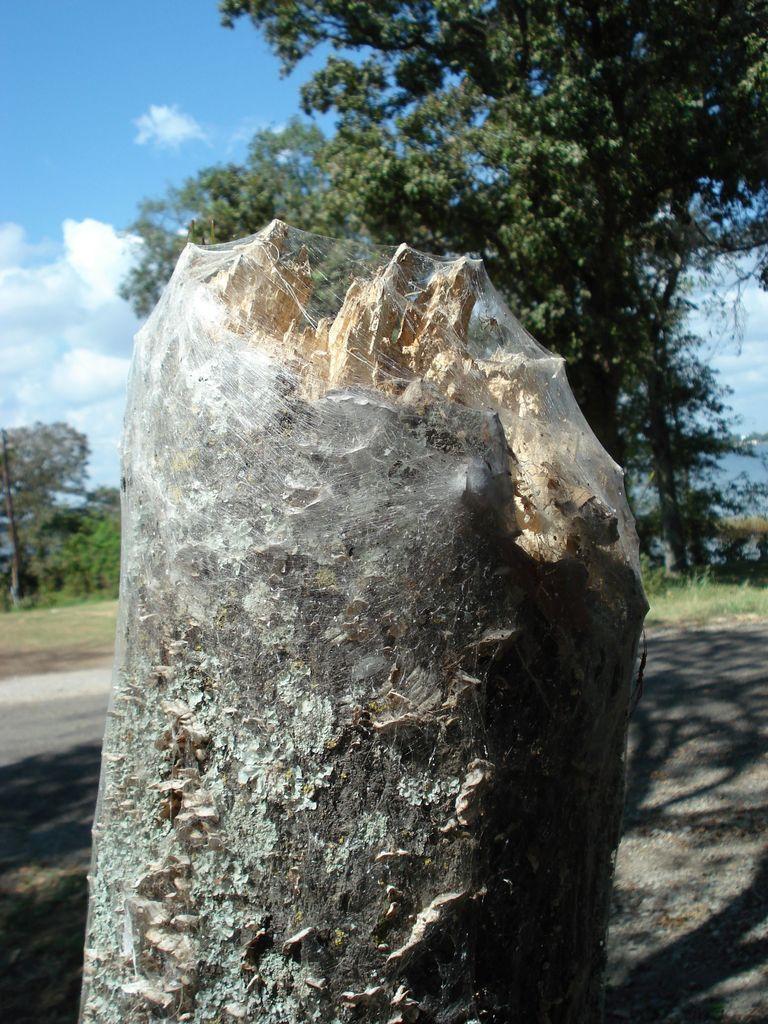In one or two sentences, can you explain what this image depicts? In this picture there is a broken leg in the center of the image and there are trees in the background area of the image. 